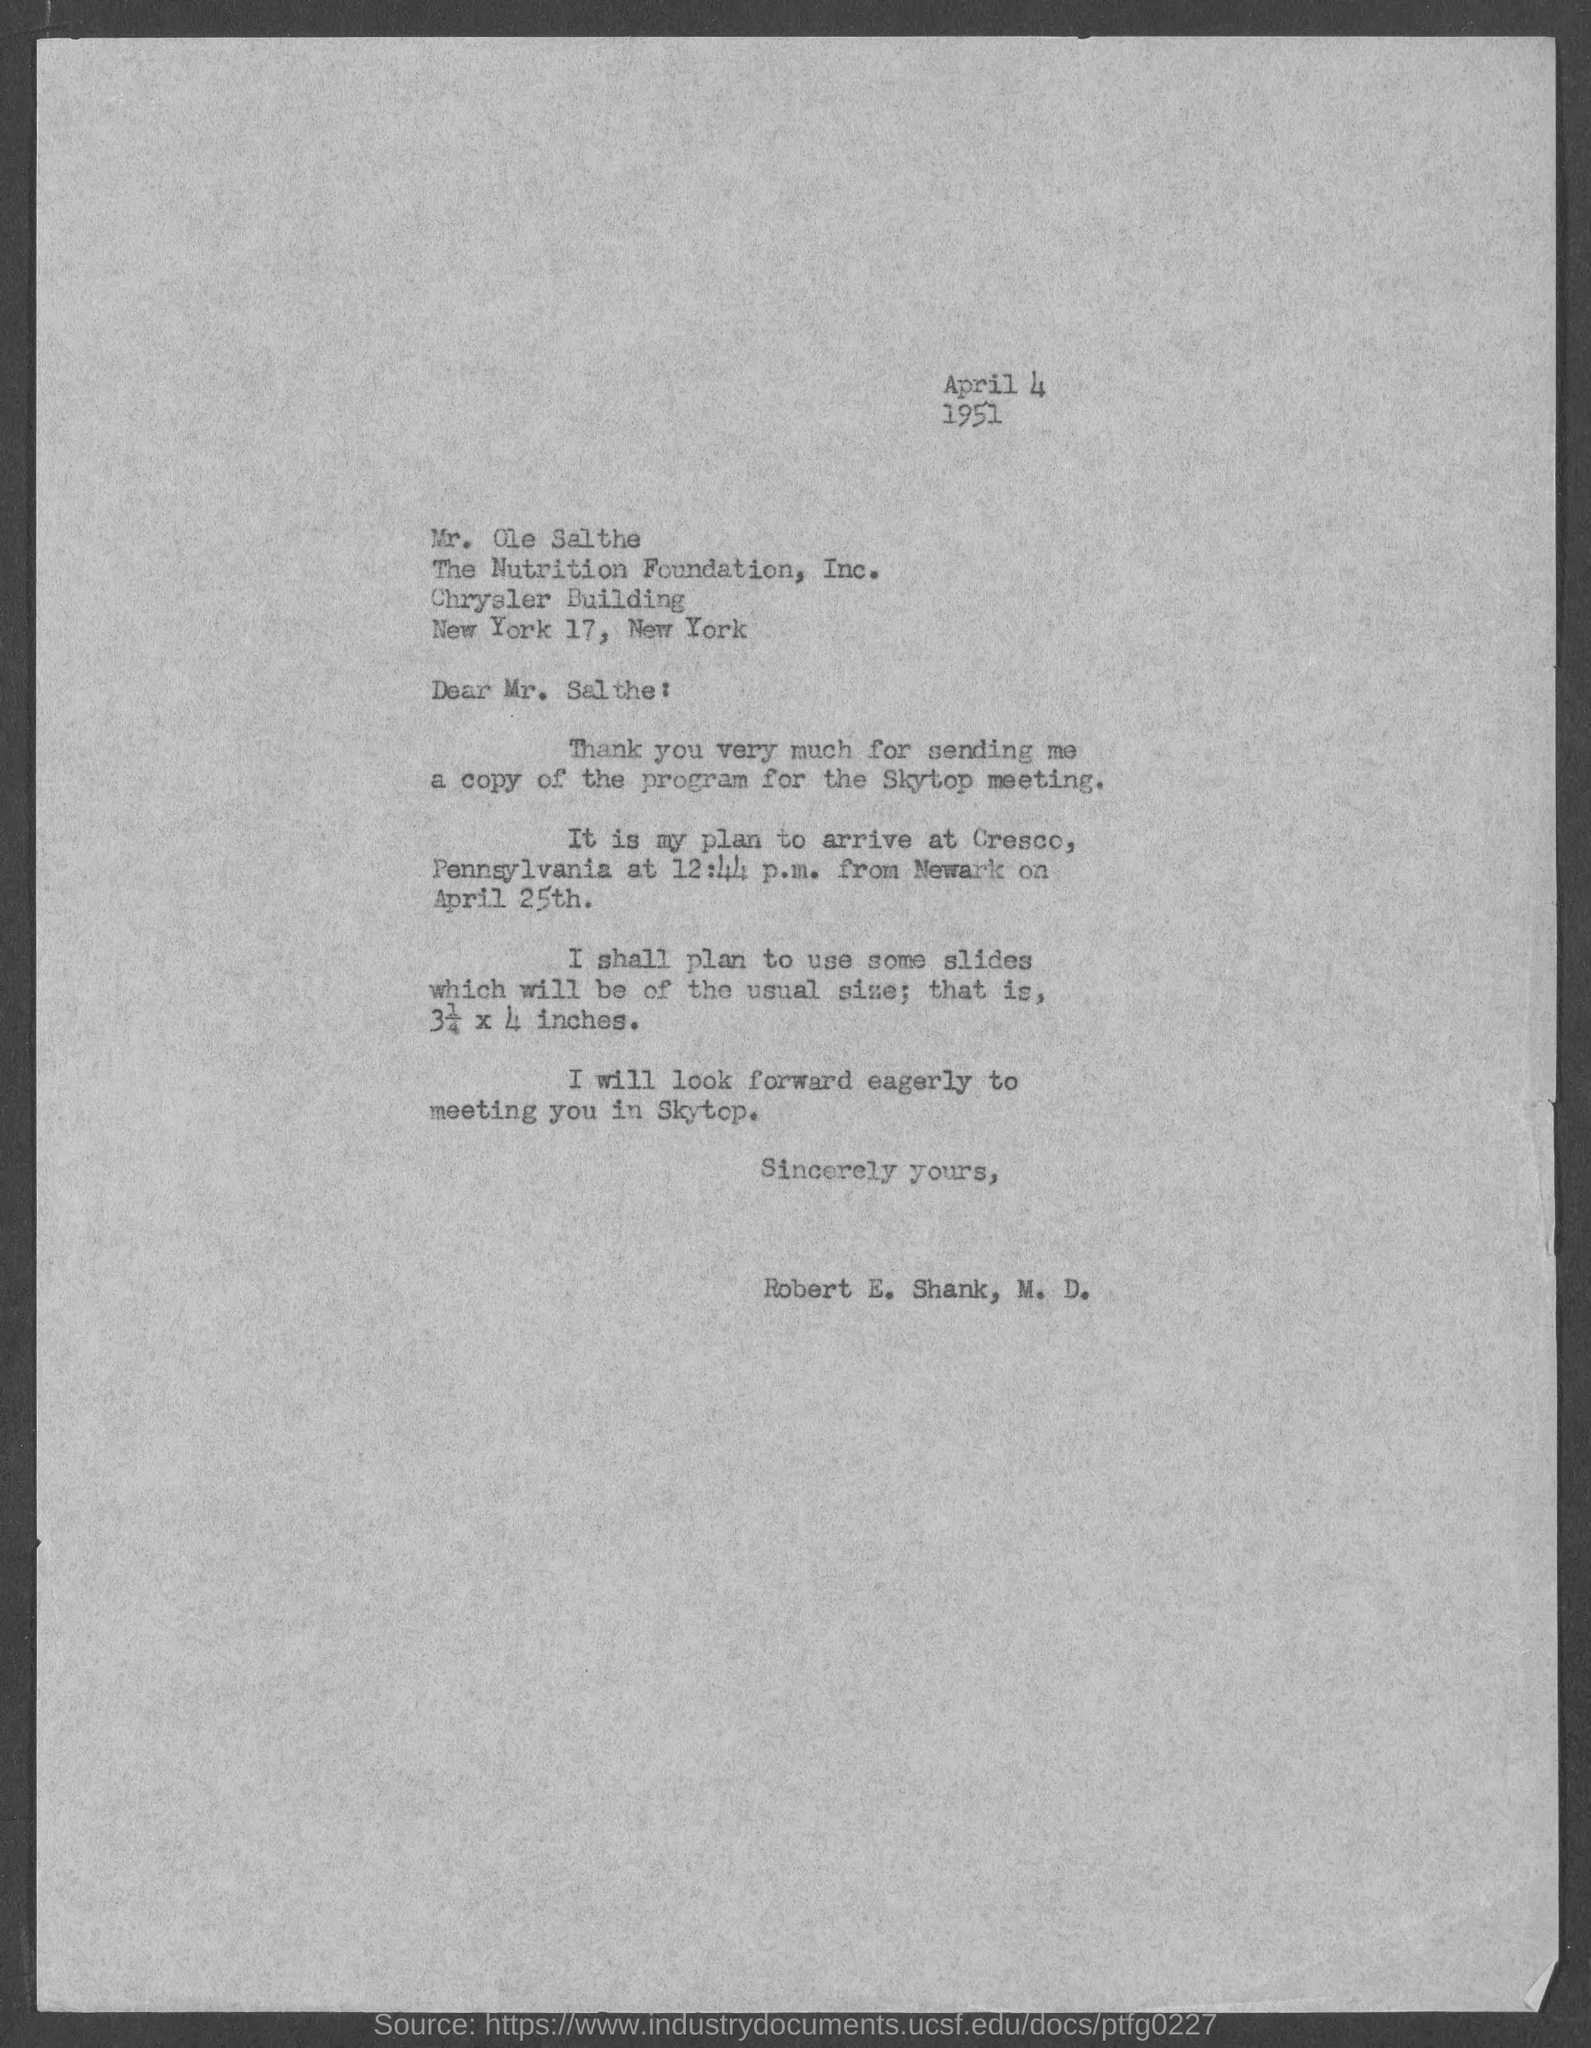Outline some significant characteristics in this image. The document indicates that the date mentioned at the top of the document is April 4, 1951. The time mentioned in the letter is 12:44 p.m. 